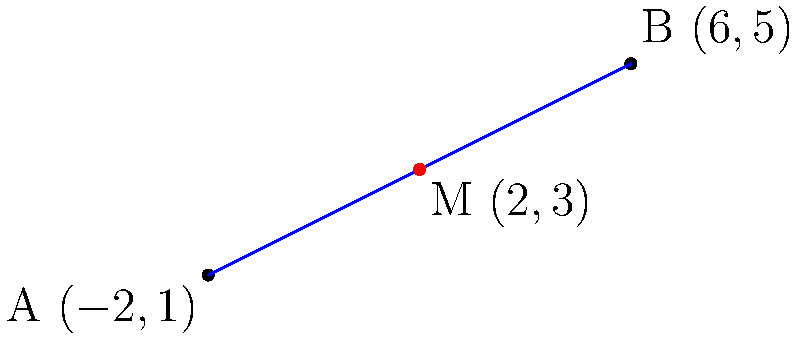As a freelance writer, you're planning to meet a potential client for a consultation. You're located at point A (-2, 1), and the client is at point B (6, 5). To make the meeting fair and convenient for both parties, you decide to meet at the midpoint between your locations. What are the coordinates of the ideal meeting point M? To find the midpoint M between two points A(x₁, y₁) and B(x₂, y₂), we use the midpoint formula:

$$ M = (\frac{x_1 + x_2}{2}, \frac{y_1 + y_2}{2}) $$

Given:
- Point A: (-2, 1)
- Point B: (6, 5)

Step 1: Calculate the x-coordinate of the midpoint:
$$ x_M = \frac{x_1 + x_2}{2} = \frac{-2 + 6}{2} = \frac{4}{2} = 2 $$

Step 2: Calculate the y-coordinate of the midpoint:
$$ y_M = \frac{y_1 + y_2}{2} = \frac{1 + 5}{2} = \frac{6}{2} = 3 $$

Step 3: Combine the x and y coordinates to get the midpoint M:
$$ M = (2, 3) $$

Therefore, the ideal meeting location for you and your client is at the point (2, 3).
Answer: (2, 3) 